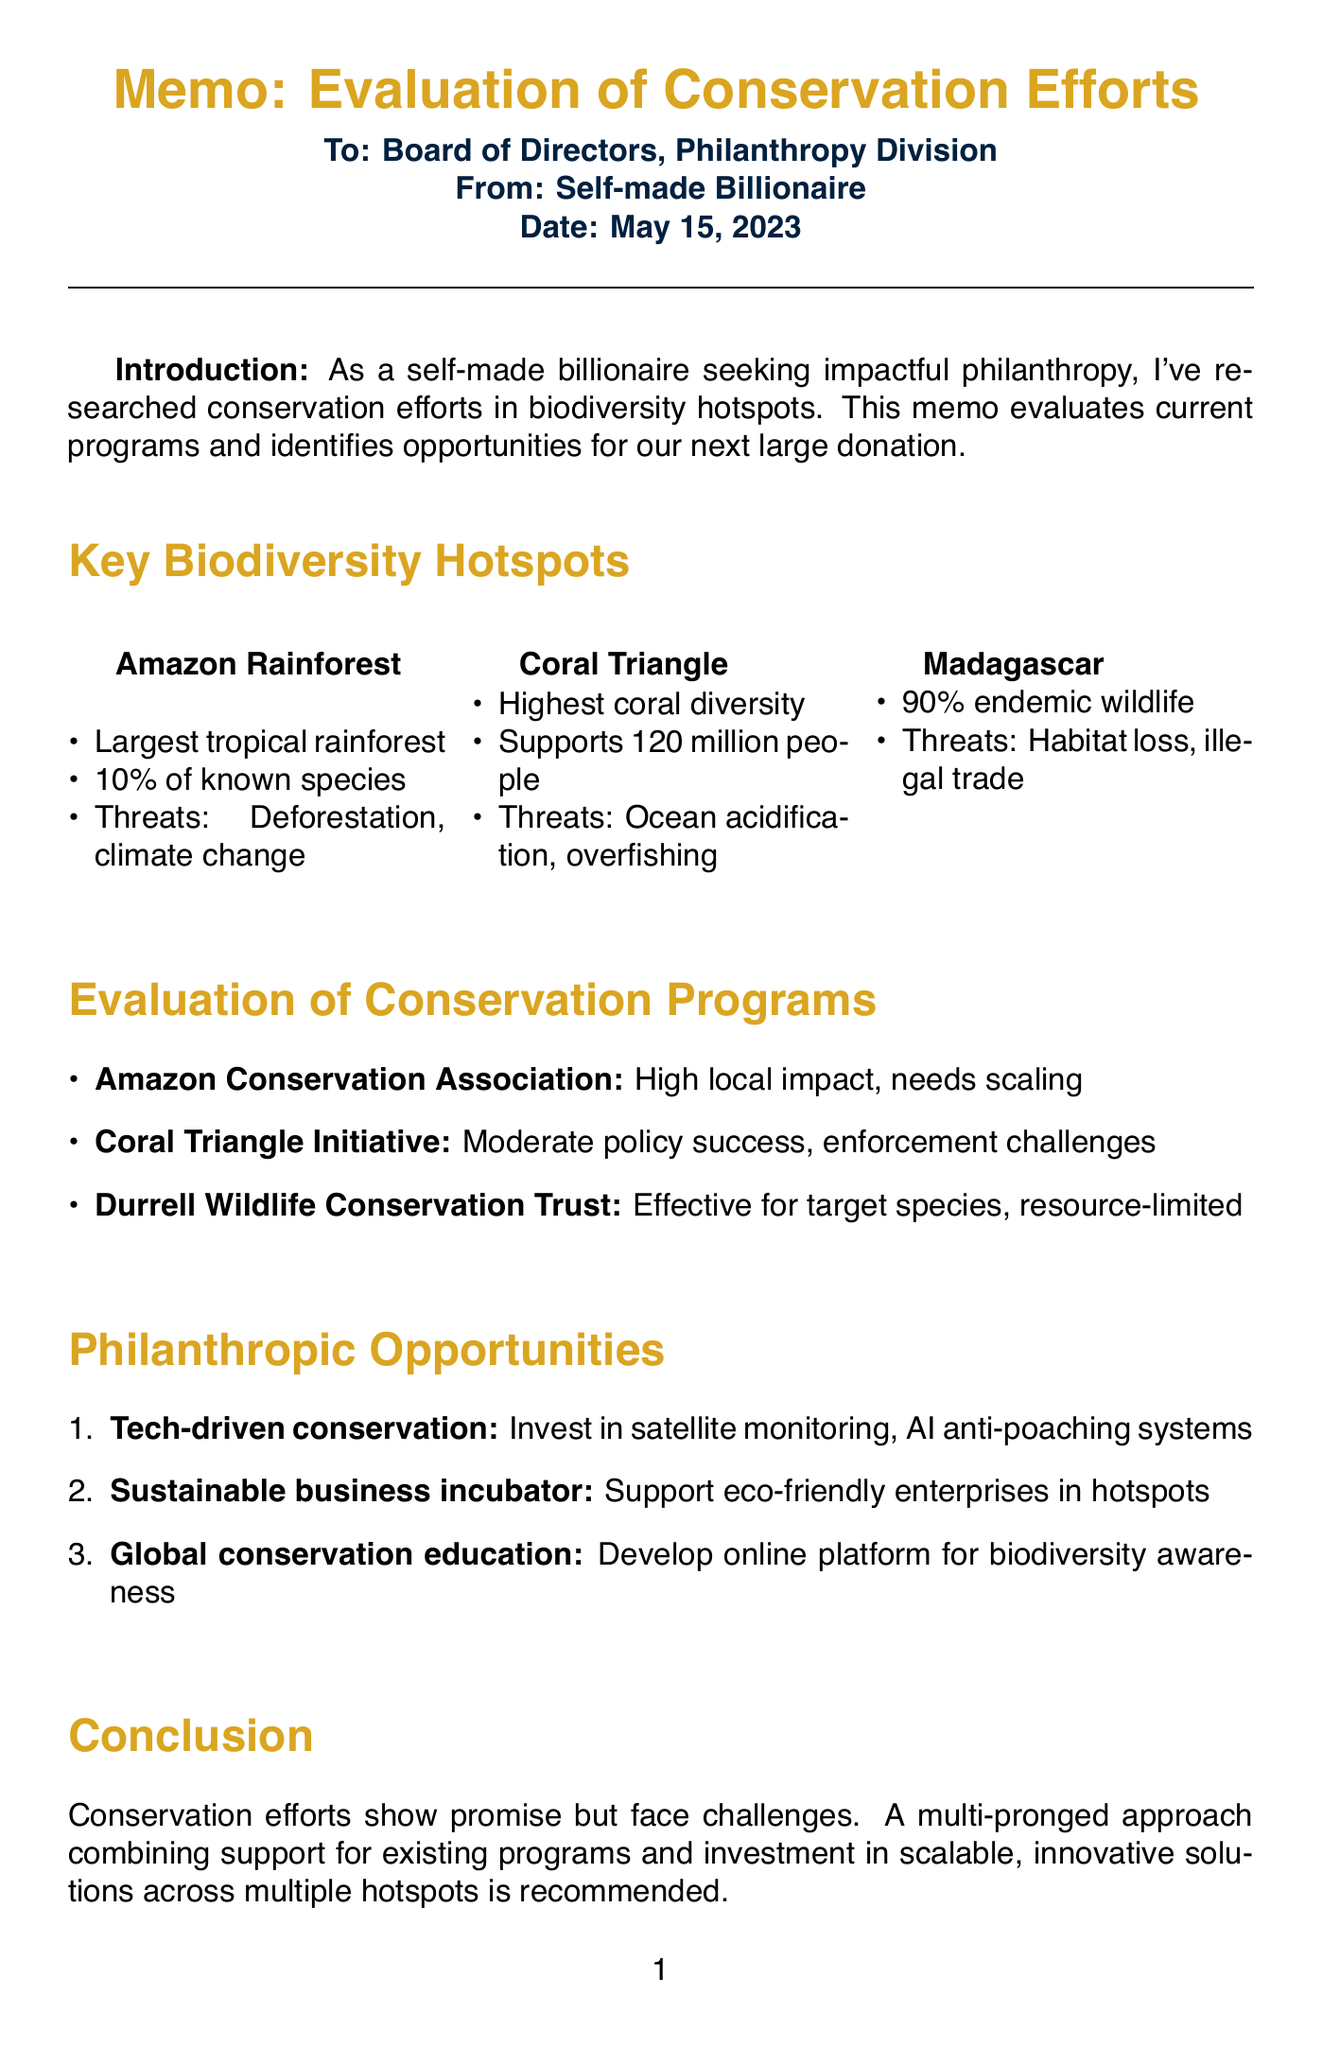what is the date of the memo? The date is explicitly stated in the document header.
Answer: May 15, 2023 who is the recipient of the memo? The recipient is mentioned in the document header.
Answer: Board of Directors, Philanthropy Division what is one of the key initiatives of the Amazon Conservation Association? The key initiatives are listed under the conservation programs section.
Answer: Sustainable agroforestry which biodiversity hotspot is home to 90% of wildlife found nowhere else on Earth? This information is provided in the biodiversity hotspots section.
Answer: Madagascar what is a philanthropic opportunity mentioned in the memo? The opportunities are detailed in the philanthropic opportunities section.
Answer: Tech-driven conservation how effective has the Coral Triangle Initiative been according to the document? Effectiveness is described in the evaluation of conservation programs section.
Answer: Moderate success in policy implementation what threats are mentioned for the Coral Triangle? The threats for each hotspot are listed in the biodiversity hotspots section.
Answer: Ocean acidification what are the evaluation metrics listed in the document? The evaluation metrics are outlined in a dedicated section of the memo.
Answer: Species population trends 